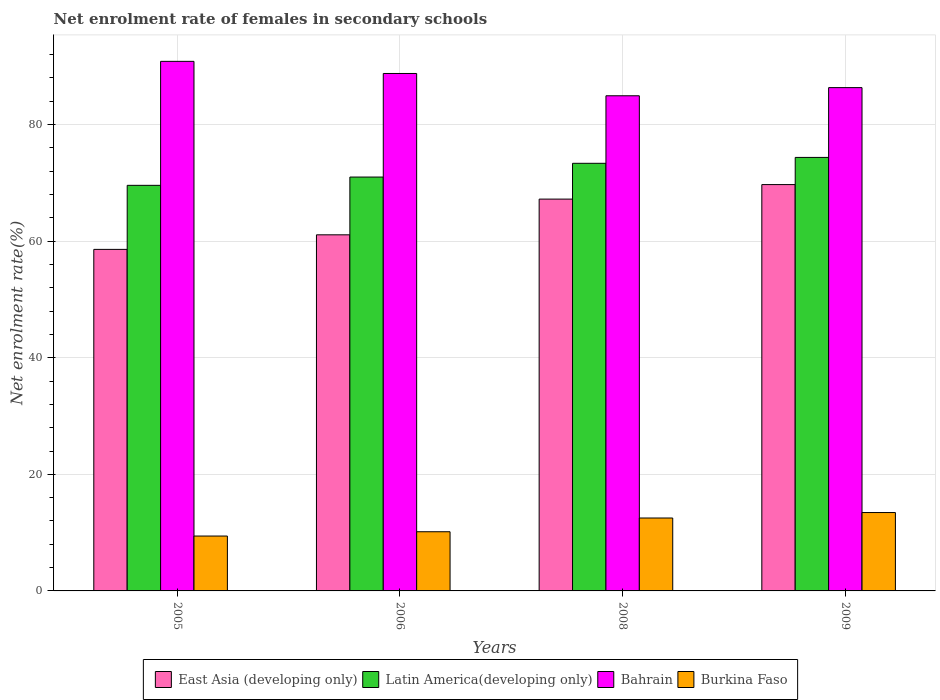How many different coloured bars are there?
Make the answer very short. 4. How many groups of bars are there?
Keep it short and to the point. 4. Are the number of bars on each tick of the X-axis equal?
Ensure brevity in your answer.  Yes. In how many cases, is the number of bars for a given year not equal to the number of legend labels?
Offer a very short reply. 0. What is the net enrolment rate of females in secondary schools in East Asia (developing only) in 2009?
Your response must be concise. 69.71. Across all years, what is the maximum net enrolment rate of females in secondary schools in Burkina Faso?
Your answer should be compact. 13.45. Across all years, what is the minimum net enrolment rate of females in secondary schools in Burkina Faso?
Provide a succinct answer. 9.42. In which year was the net enrolment rate of females in secondary schools in East Asia (developing only) minimum?
Give a very brief answer. 2005. What is the total net enrolment rate of females in secondary schools in Bahrain in the graph?
Your response must be concise. 350.91. What is the difference between the net enrolment rate of females in secondary schools in Burkina Faso in 2006 and that in 2008?
Offer a terse response. -2.36. What is the difference between the net enrolment rate of females in secondary schools in Burkina Faso in 2005 and the net enrolment rate of females in secondary schools in Bahrain in 2006?
Give a very brief answer. -79.35. What is the average net enrolment rate of females in secondary schools in Bahrain per year?
Your answer should be very brief. 87.73. In the year 2006, what is the difference between the net enrolment rate of females in secondary schools in Bahrain and net enrolment rate of females in secondary schools in Latin America(developing only)?
Your answer should be very brief. 17.77. In how many years, is the net enrolment rate of females in secondary schools in Burkina Faso greater than 20 %?
Your answer should be very brief. 0. What is the ratio of the net enrolment rate of females in secondary schools in Bahrain in 2005 to that in 2006?
Your answer should be very brief. 1.02. Is the difference between the net enrolment rate of females in secondary schools in Bahrain in 2005 and 2008 greater than the difference between the net enrolment rate of females in secondary schools in Latin America(developing only) in 2005 and 2008?
Your response must be concise. Yes. What is the difference between the highest and the second highest net enrolment rate of females in secondary schools in Bahrain?
Make the answer very short. 2.08. What is the difference between the highest and the lowest net enrolment rate of females in secondary schools in Bahrain?
Your response must be concise. 5.91. In how many years, is the net enrolment rate of females in secondary schools in East Asia (developing only) greater than the average net enrolment rate of females in secondary schools in East Asia (developing only) taken over all years?
Give a very brief answer. 2. Is it the case that in every year, the sum of the net enrolment rate of females in secondary schools in East Asia (developing only) and net enrolment rate of females in secondary schools in Bahrain is greater than the sum of net enrolment rate of females in secondary schools in Burkina Faso and net enrolment rate of females in secondary schools in Latin America(developing only)?
Ensure brevity in your answer.  Yes. What does the 2nd bar from the left in 2005 represents?
Offer a very short reply. Latin America(developing only). What does the 1st bar from the right in 2009 represents?
Your answer should be compact. Burkina Faso. Is it the case that in every year, the sum of the net enrolment rate of females in secondary schools in Bahrain and net enrolment rate of females in secondary schools in Burkina Faso is greater than the net enrolment rate of females in secondary schools in Latin America(developing only)?
Provide a short and direct response. Yes. How many bars are there?
Your answer should be compact. 16. Are all the bars in the graph horizontal?
Offer a terse response. No. How many years are there in the graph?
Offer a terse response. 4. Are the values on the major ticks of Y-axis written in scientific E-notation?
Ensure brevity in your answer.  No. Where does the legend appear in the graph?
Provide a succinct answer. Bottom center. How many legend labels are there?
Keep it short and to the point. 4. What is the title of the graph?
Make the answer very short. Net enrolment rate of females in secondary schools. Does "Solomon Islands" appear as one of the legend labels in the graph?
Your answer should be very brief. No. What is the label or title of the Y-axis?
Your answer should be compact. Net enrolment rate(%). What is the Net enrolment rate(%) of East Asia (developing only) in 2005?
Your answer should be compact. 58.59. What is the Net enrolment rate(%) of Latin America(developing only) in 2005?
Make the answer very short. 69.58. What is the Net enrolment rate(%) of Bahrain in 2005?
Give a very brief answer. 90.85. What is the Net enrolment rate(%) of Burkina Faso in 2005?
Your answer should be compact. 9.42. What is the Net enrolment rate(%) in East Asia (developing only) in 2006?
Give a very brief answer. 61.09. What is the Net enrolment rate(%) in Latin America(developing only) in 2006?
Offer a very short reply. 71. What is the Net enrolment rate(%) in Bahrain in 2006?
Your response must be concise. 88.77. What is the Net enrolment rate(%) of Burkina Faso in 2006?
Give a very brief answer. 10.15. What is the Net enrolment rate(%) in East Asia (developing only) in 2008?
Provide a short and direct response. 67.22. What is the Net enrolment rate(%) in Latin America(developing only) in 2008?
Your response must be concise. 73.36. What is the Net enrolment rate(%) of Bahrain in 2008?
Give a very brief answer. 84.95. What is the Net enrolment rate(%) in Burkina Faso in 2008?
Provide a short and direct response. 12.51. What is the Net enrolment rate(%) of East Asia (developing only) in 2009?
Offer a very short reply. 69.71. What is the Net enrolment rate(%) of Latin America(developing only) in 2009?
Your answer should be compact. 74.37. What is the Net enrolment rate(%) of Bahrain in 2009?
Keep it short and to the point. 86.35. What is the Net enrolment rate(%) of Burkina Faso in 2009?
Ensure brevity in your answer.  13.45. Across all years, what is the maximum Net enrolment rate(%) of East Asia (developing only)?
Make the answer very short. 69.71. Across all years, what is the maximum Net enrolment rate(%) of Latin America(developing only)?
Offer a very short reply. 74.37. Across all years, what is the maximum Net enrolment rate(%) of Bahrain?
Provide a succinct answer. 90.85. Across all years, what is the maximum Net enrolment rate(%) in Burkina Faso?
Your response must be concise. 13.45. Across all years, what is the minimum Net enrolment rate(%) of East Asia (developing only)?
Keep it short and to the point. 58.59. Across all years, what is the minimum Net enrolment rate(%) of Latin America(developing only)?
Offer a terse response. 69.58. Across all years, what is the minimum Net enrolment rate(%) in Bahrain?
Offer a very short reply. 84.95. Across all years, what is the minimum Net enrolment rate(%) in Burkina Faso?
Your answer should be compact. 9.42. What is the total Net enrolment rate(%) in East Asia (developing only) in the graph?
Give a very brief answer. 256.61. What is the total Net enrolment rate(%) of Latin America(developing only) in the graph?
Your answer should be very brief. 288.31. What is the total Net enrolment rate(%) in Bahrain in the graph?
Make the answer very short. 350.91. What is the total Net enrolment rate(%) of Burkina Faso in the graph?
Provide a succinct answer. 45.52. What is the difference between the Net enrolment rate(%) of East Asia (developing only) in 2005 and that in 2006?
Your answer should be compact. -2.5. What is the difference between the Net enrolment rate(%) in Latin America(developing only) in 2005 and that in 2006?
Your response must be concise. -1.42. What is the difference between the Net enrolment rate(%) of Bahrain in 2005 and that in 2006?
Provide a succinct answer. 2.08. What is the difference between the Net enrolment rate(%) in Burkina Faso in 2005 and that in 2006?
Offer a very short reply. -0.74. What is the difference between the Net enrolment rate(%) of East Asia (developing only) in 2005 and that in 2008?
Provide a short and direct response. -8.63. What is the difference between the Net enrolment rate(%) in Latin America(developing only) in 2005 and that in 2008?
Give a very brief answer. -3.78. What is the difference between the Net enrolment rate(%) of Bahrain in 2005 and that in 2008?
Ensure brevity in your answer.  5.91. What is the difference between the Net enrolment rate(%) in Burkina Faso in 2005 and that in 2008?
Keep it short and to the point. -3.09. What is the difference between the Net enrolment rate(%) of East Asia (developing only) in 2005 and that in 2009?
Your answer should be very brief. -11.12. What is the difference between the Net enrolment rate(%) of Latin America(developing only) in 2005 and that in 2009?
Provide a succinct answer. -4.79. What is the difference between the Net enrolment rate(%) in Bahrain in 2005 and that in 2009?
Your answer should be very brief. 4.5. What is the difference between the Net enrolment rate(%) of Burkina Faso in 2005 and that in 2009?
Give a very brief answer. -4.03. What is the difference between the Net enrolment rate(%) in East Asia (developing only) in 2006 and that in 2008?
Offer a terse response. -6.13. What is the difference between the Net enrolment rate(%) in Latin America(developing only) in 2006 and that in 2008?
Ensure brevity in your answer.  -2.36. What is the difference between the Net enrolment rate(%) in Bahrain in 2006 and that in 2008?
Offer a terse response. 3.83. What is the difference between the Net enrolment rate(%) of Burkina Faso in 2006 and that in 2008?
Give a very brief answer. -2.36. What is the difference between the Net enrolment rate(%) in East Asia (developing only) in 2006 and that in 2009?
Keep it short and to the point. -8.62. What is the difference between the Net enrolment rate(%) of Latin America(developing only) in 2006 and that in 2009?
Offer a terse response. -3.37. What is the difference between the Net enrolment rate(%) of Bahrain in 2006 and that in 2009?
Your response must be concise. 2.42. What is the difference between the Net enrolment rate(%) of Burkina Faso in 2006 and that in 2009?
Give a very brief answer. -3.3. What is the difference between the Net enrolment rate(%) in East Asia (developing only) in 2008 and that in 2009?
Make the answer very short. -2.49. What is the difference between the Net enrolment rate(%) in Latin America(developing only) in 2008 and that in 2009?
Offer a terse response. -1.01. What is the difference between the Net enrolment rate(%) in Bahrain in 2008 and that in 2009?
Offer a terse response. -1.4. What is the difference between the Net enrolment rate(%) of Burkina Faso in 2008 and that in 2009?
Make the answer very short. -0.94. What is the difference between the Net enrolment rate(%) in East Asia (developing only) in 2005 and the Net enrolment rate(%) in Latin America(developing only) in 2006?
Provide a succinct answer. -12.41. What is the difference between the Net enrolment rate(%) in East Asia (developing only) in 2005 and the Net enrolment rate(%) in Bahrain in 2006?
Your answer should be compact. -30.18. What is the difference between the Net enrolment rate(%) in East Asia (developing only) in 2005 and the Net enrolment rate(%) in Burkina Faso in 2006?
Offer a terse response. 48.44. What is the difference between the Net enrolment rate(%) in Latin America(developing only) in 2005 and the Net enrolment rate(%) in Bahrain in 2006?
Make the answer very short. -19.19. What is the difference between the Net enrolment rate(%) of Latin America(developing only) in 2005 and the Net enrolment rate(%) of Burkina Faso in 2006?
Give a very brief answer. 59.43. What is the difference between the Net enrolment rate(%) in Bahrain in 2005 and the Net enrolment rate(%) in Burkina Faso in 2006?
Provide a short and direct response. 80.7. What is the difference between the Net enrolment rate(%) in East Asia (developing only) in 2005 and the Net enrolment rate(%) in Latin America(developing only) in 2008?
Offer a very short reply. -14.77. What is the difference between the Net enrolment rate(%) in East Asia (developing only) in 2005 and the Net enrolment rate(%) in Bahrain in 2008?
Keep it short and to the point. -26.35. What is the difference between the Net enrolment rate(%) in East Asia (developing only) in 2005 and the Net enrolment rate(%) in Burkina Faso in 2008?
Provide a short and direct response. 46.08. What is the difference between the Net enrolment rate(%) in Latin America(developing only) in 2005 and the Net enrolment rate(%) in Bahrain in 2008?
Your answer should be very brief. -15.36. What is the difference between the Net enrolment rate(%) of Latin America(developing only) in 2005 and the Net enrolment rate(%) of Burkina Faso in 2008?
Your answer should be compact. 57.07. What is the difference between the Net enrolment rate(%) in Bahrain in 2005 and the Net enrolment rate(%) in Burkina Faso in 2008?
Offer a terse response. 78.34. What is the difference between the Net enrolment rate(%) of East Asia (developing only) in 2005 and the Net enrolment rate(%) of Latin America(developing only) in 2009?
Offer a terse response. -15.78. What is the difference between the Net enrolment rate(%) in East Asia (developing only) in 2005 and the Net enrolment rate(%) in Bahrain in 2009?
Ensure brevity in your answer.  -27.75. What is the difference between the Net enrolment rate(%) of East Asia (developing only) in 2005 and the Net enrolment rate(%) of Burkina Faso in 2009?
Offer a very short reply. 45.14. What is the difference between the Net enrolment rate(%) in Latin America(developing only) in 2005 and the Net enrolment rate(%) in Bahrain in 2009?
Keep it short and to the point. -16.77. What is the difference between the Net enrolment rate(%) in Latin America(developing only) in 2005 and the Net enrolment rate(%) in Burkina Faso in 2009?
Ensure brevity in your answer.  56.13. What is the difference between the Net enrolment rate(%) in Bahrain in 2005 and the Net enrolment rate(%) in Burkina Faso in 2009?
Offer a very short reply. 77.4. What is the difference between the Net enrolment rate(%) of East Asia (developing only) in 2006 and the Net enrolment rate(%) of Latin America(developing only) in 2008?
Ensure brevity in your answer.  -12.27. What is the difference between the Net enrolment rate(%) in East Asia (developing only) in 2006 and the Net enrolment rate(%) in Bahrain in 2008?
Ensure brevity in your answer.  -23.85. What is the difference between the Net enrolment rate(%) of East Asia (developing only) in 2006 and the Net enrolment rate(%) of Burkina Faso in 2008?
Your response must be concise. 48.58. What is the difference between the Net enrolment rate(%) of Latin America(developing only) in 2006 and the Net enrolment rate(%) of Bahrain in 2008?
Provide a short and direct response. -13.94. What is the difference between the Net enrolment rate(%) of Latin America(developing only) in 2006 and the Net enrolment rate(%) of Burkina Faso in 2008?
Provide a short and direct response. 58.49. What is the difference between the Net enrolment rate(%) in Bahrain in 2006 and the Net enrolment rate(%) in Burkina Faso in 2008?
Your answer should be very brief. 76.26. What is the difference between the Net enrolment rate(%) of East Asia (developing only) in 2006 and the Net enrolment rate(%) of Latin America(developing only) in 2009?
Keep it short and to the point. -13.28. What is the difference between the Net enrolment rate(%) of East Asia (developing only) in 2006 and the Net enrolment rate(%) of Bahrain in 2009?
Ensure brevity in your answer.  -25.25. What is the difference between the Net enrolment rate(%) of East Asia (developing only) in 2006 and the Net enrolment rate(%) of Burkina Faso in 2009?
Give a very brief answer. 47.64. What is the difference between the Net enrolment rate(%) of Latin America(developing only) in 2006 and the Net enrolment rate(%) of Bahrain in 2009?
Your answer should be compact. -15.34. What is the difference between the Net enrolment rate(%) in Latin America(developing only) in 2006 and the Net enrolment rate(%) in Burkina Faso in 2009?
Provide a short and direct response. 57.55. What is the difference between the Net enrolment rate(%) in Bahrain in 2006 and the Net enrolment rate(%) in Burkina Faso in 2009?
Your answer should be compact. 75.32. What is the difference between the Net enrolment rate(%) of East Asia (developing only) in 2008 and the Net enrolment rate(%) of Latin America(developing only) in 2009?
Give a very brief answer. -7.15. What is the difference between the Net enrolment rate(%) of East Asia (developing only) in 2008 and the Net enrolment rate(%) of Bahrain in 2009?
Ensure brevity in your answer.  -19.13. What is the difference between the Net enrolment rate(%) of East Asia (developing only) in 2008 and the Net enrolment rate(%) of Burkina Faso in 2009?
Keep it short and to the point. 53.77. What is the difference between the Net enrolment rate(%) of Latin America(developing only) in 2008 and the Net enrolment rate(%) of Bahrain in 2009?
Make the answer very short. -12.99. What is the difference between the Net enrolment rate(%) of Latin America(developing only) in 2008 and the Net enrolment rate(%) of Burkina Faso in 2009?
Provide a short and direct response. 59.91. What is the difference between the Net enrolment rate(%) in Bahrain in 2008 and the Net enrolment rate(%) in Burkina Faso in 2009?
Offer a terse response. 71.5. What is the average Net enrolment rate(%) of East Asia (developing only) per year?
Make the answer very short. 64.15. What is the average Net enrolment rate(%) of Latin America(developing only) per year?
Keep it short and to the point. 72.08. What is the average Net enrolment rate(%) in Bahrain per year?
Give a very brief answer. 87.73. What is the average Net enrolment rate(%) in Burkina Faso per year?
Provide a succinct answer. 11.38. In the year 2005, what is the difference between the Net enrolment rate(%) of East Asia (developing only) and Net enrolment rate(%) of Latin America(developing only)?
Keep it short and to the point. -10.99. In the year 2005, what is the difference between the Net enrolment rate(%) in East Asia (developing only) and Net enrolment rate(%) in Bahrain?
Ensure brevity in your answer.  -32.26. In the year 2005, what is the difference between the Net enrolment rate(%) of East Asia (developing only) and Net enrolment rate(%) of Burkina Faso?
Provide a short and direct response. 49.18. In the year 2005, what is the difference between the Net enrolment rate(%) in Latin America(developing only) and Net enrolment rate(%) in Bahrain?
Give a very brief answer. -21.27. In the year 2005, what is the difference between the Net enrolment rate(%) in Latin America(developing only) and Net enrolment rate(%) in Burkina Faso?
Your response must be concise. 60.16. In the year 2005, what is the difference between the Net enrolment rate(%) in Bahrain and Net enrolment rate(%) in Burkina Faso?
Offer a terse response. 81.43. In the year 2006, what is the difference between the Net enrolment rate(%) in East Asia (developing only) and Net enrolment rate(%) in Latin America(developing only)?
Provide a succinct answer. -9.91. In the year 2006, what is the difference between the Net enrolment rate(%) of East Asia (developing only) and Net enrolment rate(%) of Bahrain?
Offer a terse response. -27.68. In the year 2006, what is the difference between the Net enrolment rate(%) in East Asia (developing only) and Net enrolment rate(%) in Burkina Faso?
Your response must be concise. 50.94. In the year 2006, what is the difference between the Net enrolment rate(%) in Latin America(developing only) and Net enrolment rate(%) in Bahrain?
Ensure brevity in your answer.  -17.77. In the year 2006, what is the difference between the Net enrolment rate(%) in Latin America(developing only) and Net enrolment rate(%) in Burkina Faso?
Provide a short and direct response. 60.85. In the year 2006, what is the difference between the Net enrolment rate(%) in Bahrain and Net enrolment rate(%) in Burkina Faso?
Your answer should be compact. 78.62. In the year 2008, what is the difference between the Net enrolment rate(%) in East Asia (developing only) and Net enrolment rate(%) in Latin America(developing only)?
Your response must be concise. -6.14. In the year 2008, what is the difference between the Net enrolment rate(%) in East Asia (developing only) and Net enrolment rate(%) in Bahrain?
Offer a terse response. -17.73. In the year 2008, what is the difference between the Net enrolment rate(%) of East Asia (developing only) and Net enrolment rate(%) of Burkina Faso?
Offer a terse response. 54.71. In the year 2008, what is the difference between the Net enrolment rate(%) in Latin America(developing only) and Net enrolment rate(%) in Bahrain?
Your answer should be compact. -11.58. In the year 2008, what is the difference between the Net enrolment rate(%) in Latin America(developing only) and Net enrolment rate(%) in Burkina Faso?
Keep it short and to the point. 60.85. In the year 2008, what is the difference between the Net enrolment rate(%) in Bahrain and Net enrolment rate(%) in Burkina Faso?
Ensure brevity in your answer.  72.44. In the year 2009, what is the difference between the Net enrolment rate(%) of East Asia (developing only) and Net enrolment rate(%) of Latin America(developing only)?
Your answer should be compact. -4.66. In the year 2009, what is the difference between the Net enrolment rate(%) of East Asia (developing only) and Net enrolment rate(%) of Bahrain?
Provide a short and direct response. -16.64. In the year 2009, what is the difference between the Net enrolment rate(%) in East Asia (developing only) and Net enrolment rate(%) in Burkina Faso?
Provide a short and direct response. 56.26. In the year 2009, what is the difference between the Net enrolment rate(%) in Latin America(developing only) and Net enrolment rate(%) in Bahrain?
Your answer should be compact. -11.98. In the year 2009, what is the difference between the Net enrolment rate(%) in Latin America(developing only) and Net enrolment rate(%) in Burkina Faso?
Provide a succinct answer. 60.92. In the year 2009, what is the difference between the Net enrolment rate(%) of Bahrain and Net enrolment rate(%) of Burkina Faso?
Keep it short and to the point. 72.9. What is the ratio of the Net enrolment rate(%) of East Asia (developing only) in 2005 to that in 2006?
Keep it short and to the point. 0.96. What is the ratio of the Net enrolment rate(%) in Latin America(developing only) in 2005 to that in 2006?
Keep it short and to the point. 0.98. What is the ratio of the Net enrolment rate(%) of Bahrain in 2005 to that in 2006?
Give a very brief answer. 1.02. What is the ratio of the Net enrolment rate(%) of Burkina Faso in 2005 to that in 2006?
Your answer should be very brief. 0.93. What is the ratio of the Net enrolment rate(%) in East Asia (developing only) in 2005 to that in 2008?
Offer a terse response. 0.87. What is the ratio of the Net enrolment rate(%) in Latin America(developing only) in 2005 to that in 2008?
Offer a terse response. 0.95. What is the ratio of the Net enrolment rate(%) of Bahrain in 2005 to that in 2008?
Your response must be concise. 1.07. What is the ratio of the Net enrolment rate(%) in Burkina Faso in 2005 to that in 2008?
Make the answer very short. 0.75. What is the ratio of the Net enrolment rate(%) in East Asia (developing only) in 2005 to that in 2009?
Ensure brevity in your answer.  0.84. What is the ratio of the Net enrolment rate(%) in Latin America(developing only) in 2005 to that in 2009?
Your answer should be very brief. 0.94. What is the ratio of the Net enrolment rate(%) in Bahrain in 2005 to that in 2009?
Offer a very short reply. 1.05. What is the ratio of the Net enrolment rate(%) in Burkina Faso in 2005 to that in 2009?
Give a very brief answer. 0.7. What is the ratio of the Net enrolment rate(%) of East Asia (developing only) in 2006 to that in 2008?
Make the answer very short. 0.91. What is the ratio of the Net enrolment rate(%) of Latin America(developing only) in 2006 to that in 2008?
Your answer should be very brief. 0.97. What is the ratio of the Net enrolment rate(%) of Bahrain in 2006 to that in 2008?
Provide a succinct answer. 1.04. What is the ratio of the Net enrolment rate(%) in Burkina Faso in 2006 to that in 2008?
Offer a terse response. 0.81. What is the ratio of the Net enrolment rate(%) in East Asia (developing only) in 2006 to that in 2009?
Make the answer very short. 0.88. What is the ratio of the Net enrolment rate(%) of Latin America(developing only) in 2006 to that in 2009?
Provide a succinct answer. 0.95. What is the ratio of the Net enrolment rate(%) in Bahrain in 2006 to that in 2009?
Provide a short and direct response. 1.03. What is the ratio of the Net enrolment rate(%) of Burkina Faso in 2006 to that in 2009?
Your response must be concise. 0.76. What is the ratio of the Net enrolment rate(%) of Latin America(developing only) in 2008 to that in 2009?
Give a very brief answer. 0.99. What is the ratio of the Net enrolment rate(%) of Bahrain in 2008 to that in 2009?
Your answer should be compact. 0.98. What is the ratio of the Net enrolment rate(%) of Burkina Faso in 2008 to that in 2009?
Offer a terse response. 0.93. What is the difference between the highest and the second highest Net enrolment rate(%) in East Asia (developing only)?
Your response must be concise. 2.49. What is the difference between the highest and the second highest Net enrolment rate(%) of Latin America(developing only)?
Your answer should be compact. 1.01. What is the difference between the highest and the second highest Net enrolment rate(%) in Bahrain?
Ensure brevity in your answer.  2.08. What is the difference between the highest and the second highest Net enrolment rate(%) of Burkina Faso?
Make the answer very short. 0.94. What is the difference between the highest and the lowest Net enrolment rate(%) of East Asia (developing only)?
Your answer should be compact. 11.12. What is the difference between the highest and the lowest Net enrolment rate(%) of Latin America(developing only)?
Offer a terse response. 4.79. What is the difference between the highest and the lowest Net enrolment rate(%) in Bahrain?
Keep it short and to the point. 5.91. What is the difference between the highest and the lowest Net enrolment rate(%) of Burkina Faso?
Make the answer very short. 4.03. 